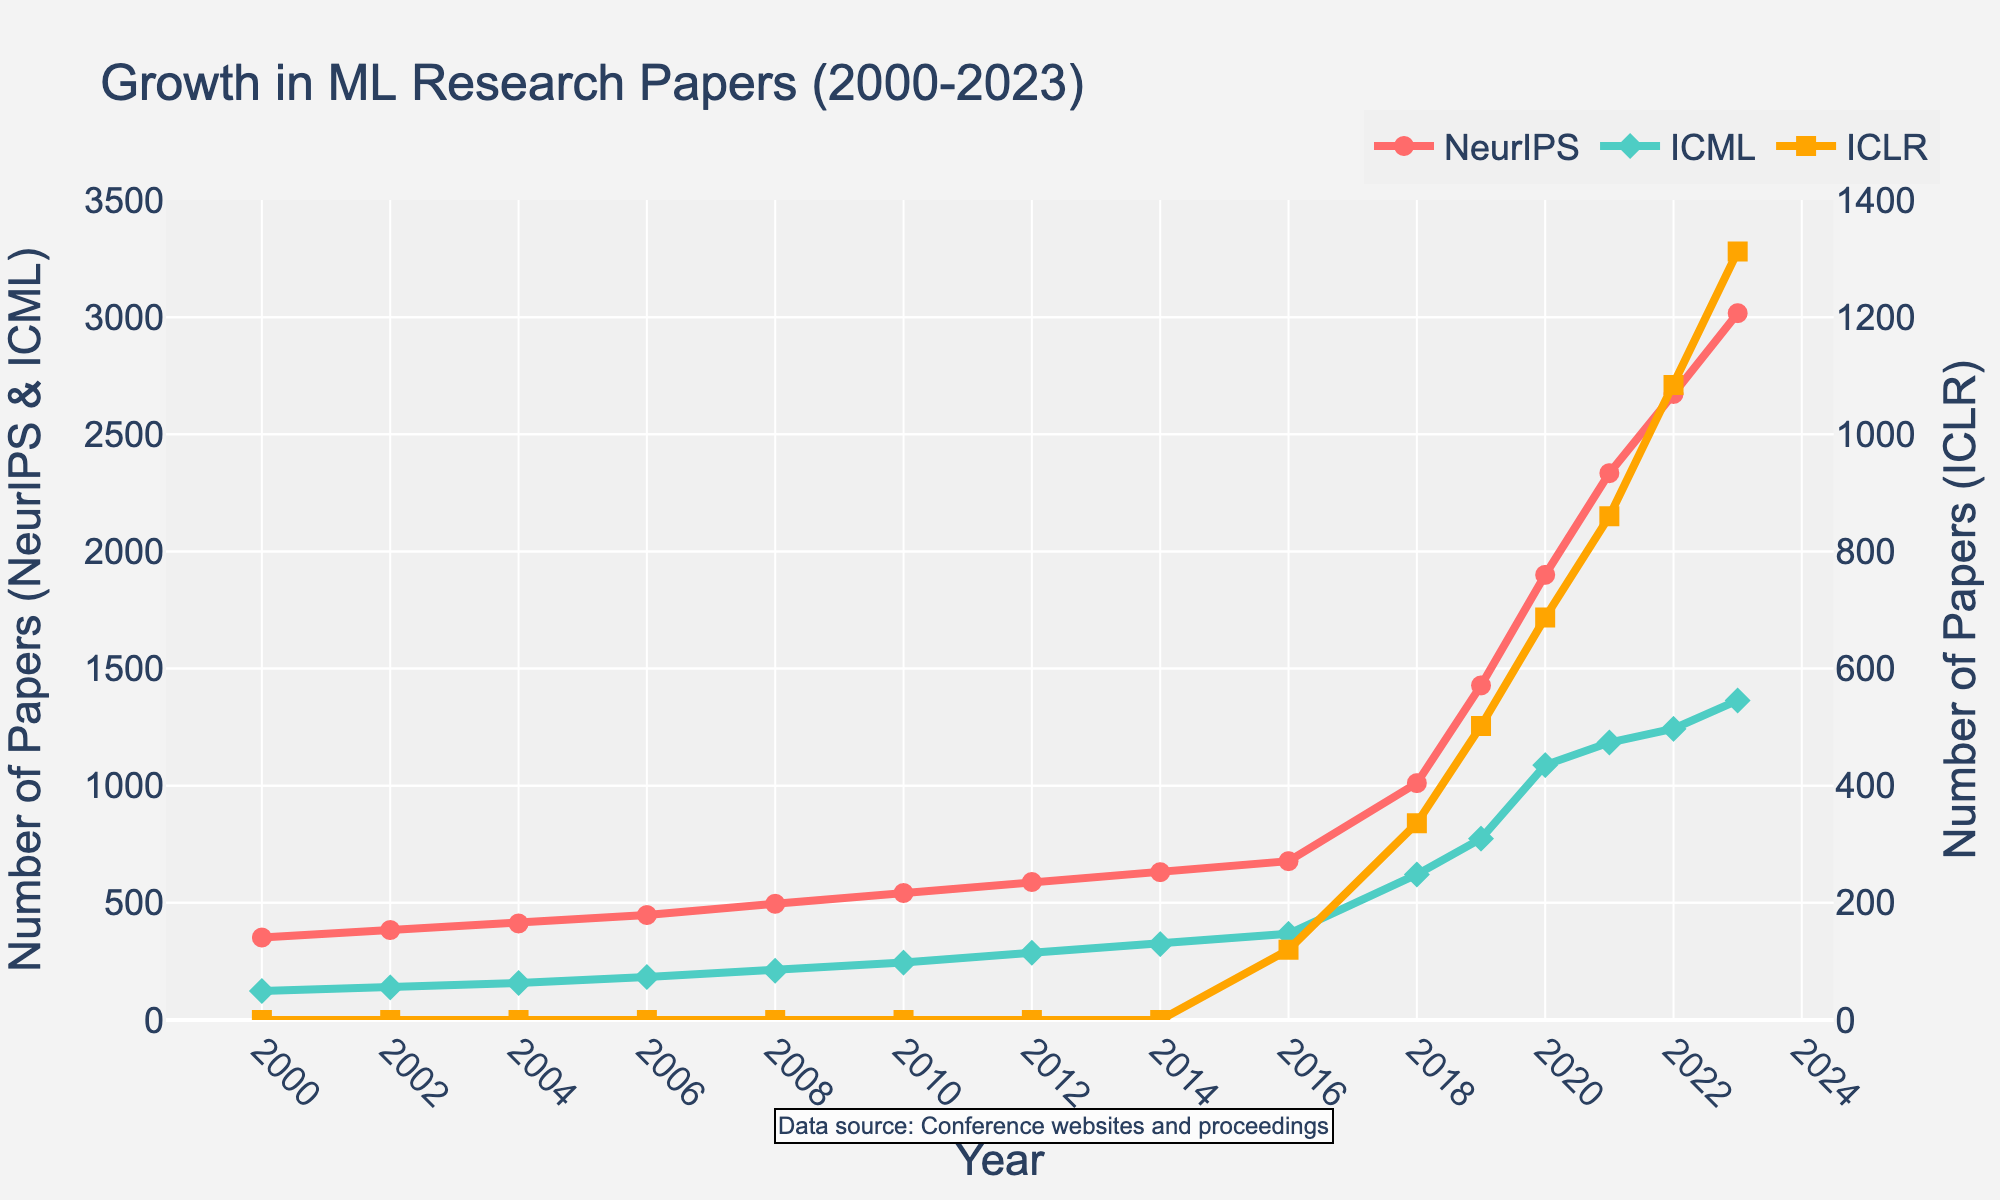What is the difference in the number of papers published in NeurIPS between 2022 and 2023? To find the difference, identify the number of papers in NeurIPS for 2022 (2672) and 2023 (3017). Then, subtract the 2022 value from the 2023 value: 3017 - 2672 = 345.
Answer: 345 Which conference had the highest number of papers published in 2023? Look at the values for 2023 across NeurIPS, ICML, and ICLR. NeurIPS has 3017, ICML has 1364, and ICLR has 1312. NeurIPS has the highest number.
Answer: NeurIPS By how much did the number of papers in ICLR increase between 2016 and 2019? Identify the values in ICLR for 2016 (120) and 2019 (502). Subtract the 2016 value from the 2019 value: 502 - 120 = 382.
Answer: 382 Which conference showed the steepest growth in the number of papers after 2016? Compare the slope of the lines for each conference from 2016 onwards. NeurIPS increased from 678 (2016) to 3017 (2023), ICML from 368 (2016) to 1364 (2023), and ICLR from 120 (2016) to 1312 (2023). NeurIPS has the steepest increase.
Answer: NeurIPS What is the average number of NeurIPS papers published annually from 2000 to 2010? Sum the number of NeurIPS papers from 2000 to 2010 (352 + 384 + 412 + 448 + 496 + 542 + 589) and divide by the number of years (7): (352 + 384 + 412 + 448 + 496 + 542 + 589) / 7 = 4520 / 7 = 645.71.
Answer: 645.71 In which year did ICLR first appear, and how many papers were published? ICLR first appears in 2016 with 120 papers. This is seen by noting the introduction of ICLR on the plot in 2016.
Answer: 2016, 120 From 2000 to 2014, which conference consistently had the highest number of papers published? Review the numbers from 2000 to 2014 for each conference. NeurIPS has higher numbers compared to ICML and ICLR was not present in this period.
Answer: NeurIPS What is the total number of papers published in 2020 across all three conferences? Sum the number of papers in NeurIPS, ICML, and ICLR for 2020: 1900 (NeurIPS) + 1088 (ICML) + 687 (ICLR) = 3675.
Answer: 3675 How did the number of ICML papers change from 2008 to 2018? Identify the number of ICML papers in 2008 (210) and 2018 (621). The change is 621 - 210 = 411.
Answer: 411 